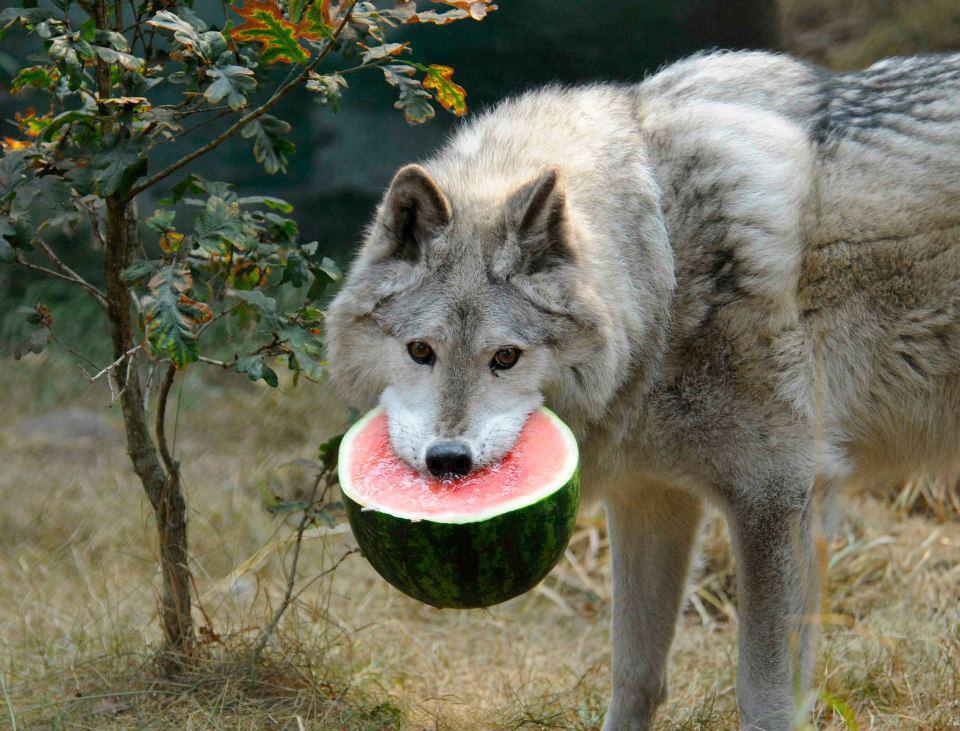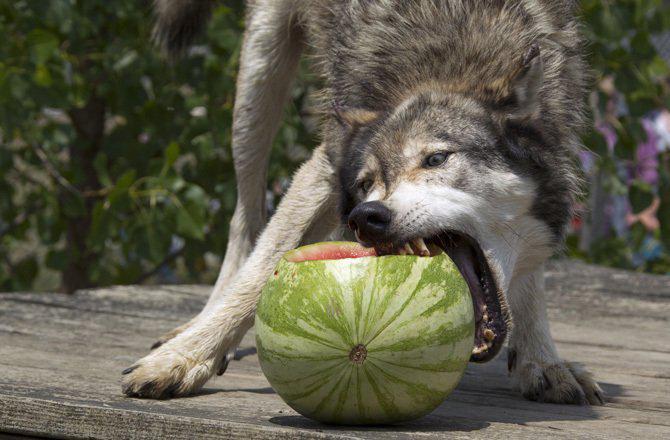The first image is the image on the left, the second image is the image on the right. Considering the images on both sides, is "The left image contains exactly one wolf." valid? Answer yes or no. Yes. The first image is the image on the left, the second image is the image on the right. Considering the images on both sides, is "There is only one wolf in at least one of the images." valid? Answer yes or no. Yes. 